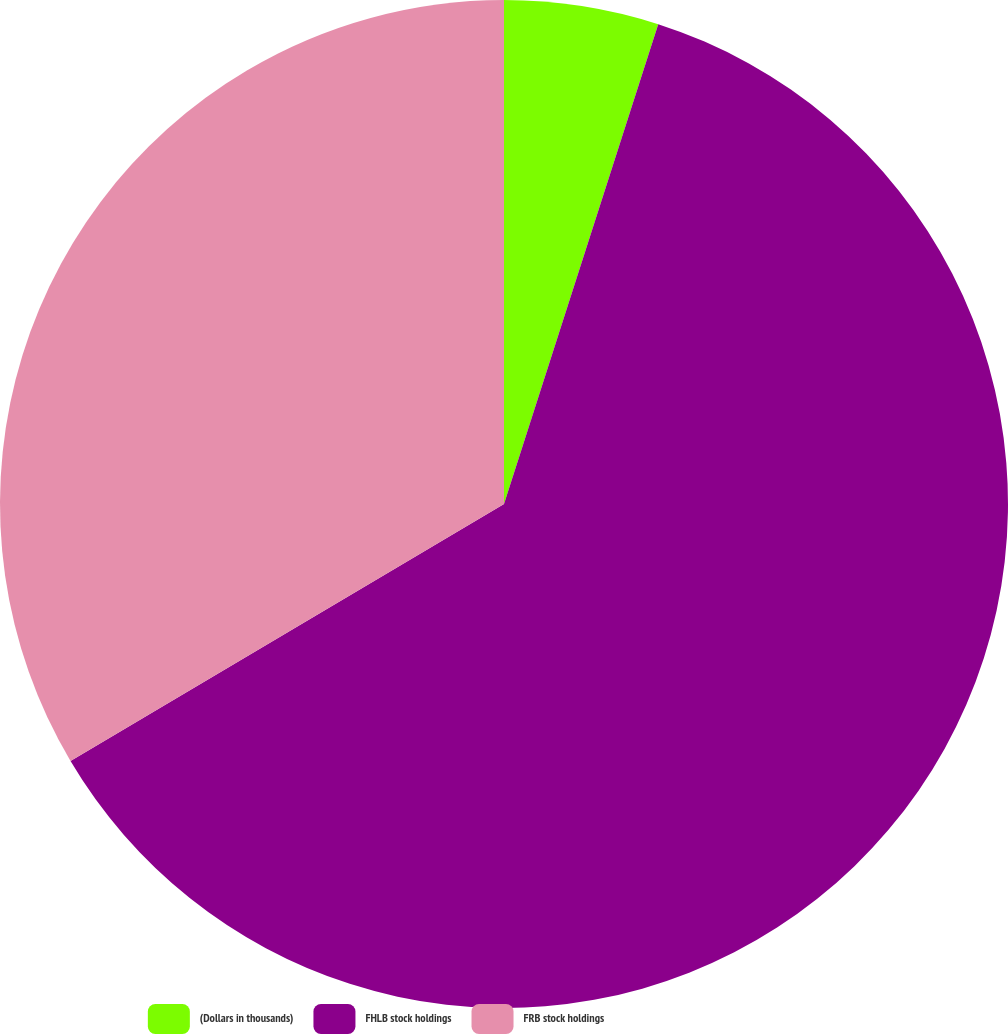<chart> <loc_0><loc_0><loc_500><loc_500><pie_chart><fcel>(Dollars in thousands)<fcel>FHLB stock holdings<fcel>FRB stock holdings<nl><fcel>4.95%<fcel>61.53%<fcel>33.52%<nl></chart> 